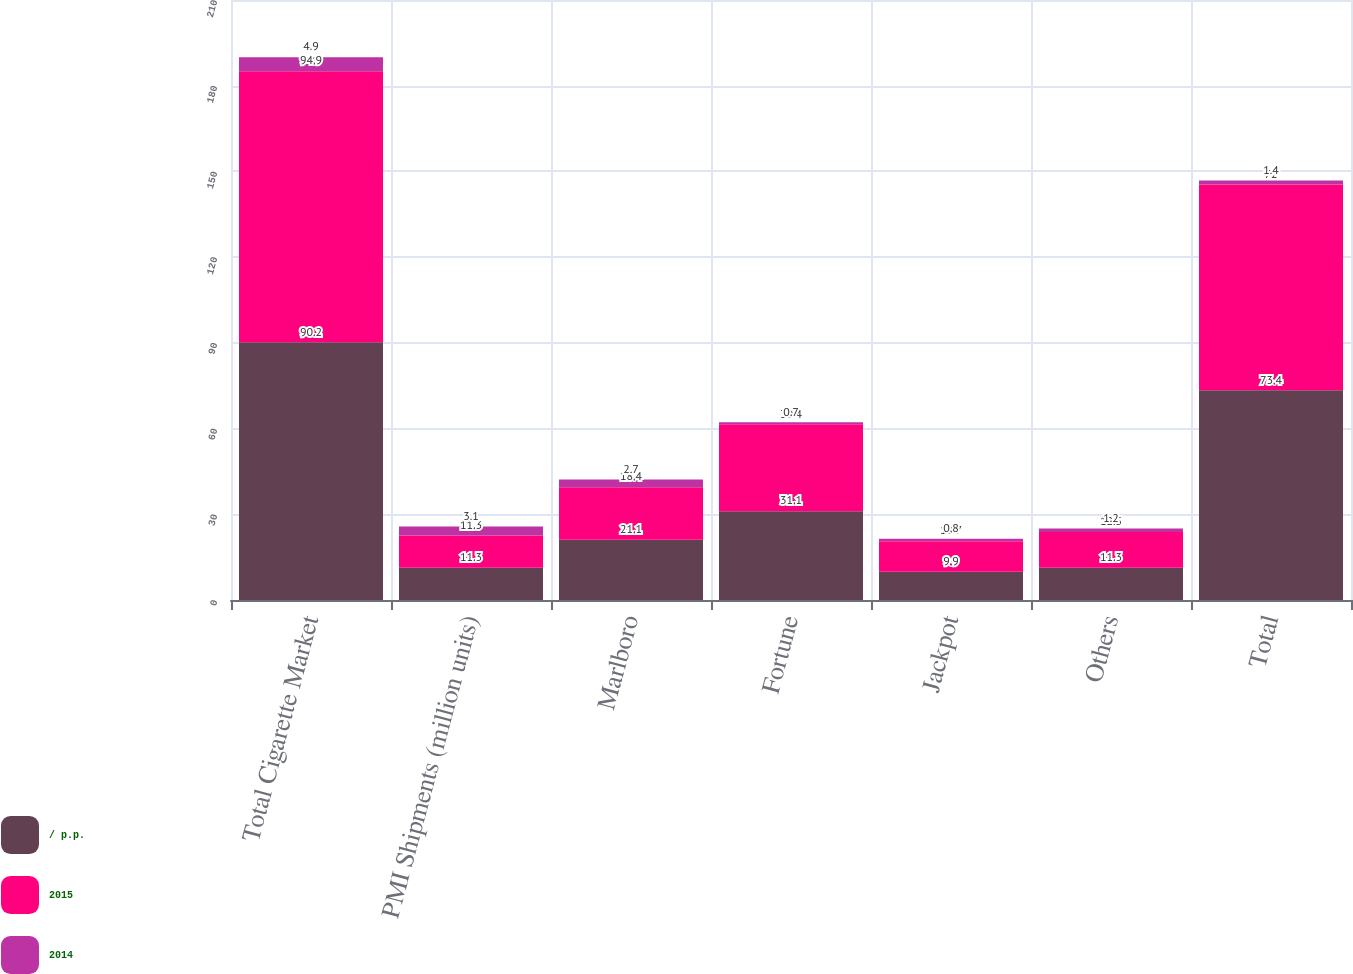<chart> <loc_0><loc_0><loc_500><loc_500><stacked_bar_chart><ecel><fcel>Total Cigarette Market<fcel>PMI Shipments (million units)<fcel>Marlboro<fcel>Fortune<fcel>Jackpot<fcel>Others<fcel>Total<nl><fcel>/ p.p.<fcel>90.2<fcel>11.3<fcel>21.1<fcel>31.1<fcel>9.9<fcel>11.3<fcel>73.4<nl><fcel>2015<fcel>94.9<fcel>11.3<fcel>18.4<fcel>30.4<fcel>10.7<fcel>12.5<fcel>72<nl><fcel>2014<fcel>4.9<fcel>3.1<fcel>2.7<fcel>0.7<fcel>0.8<fcel>1.2<fcel>1.4<nl></chart> 